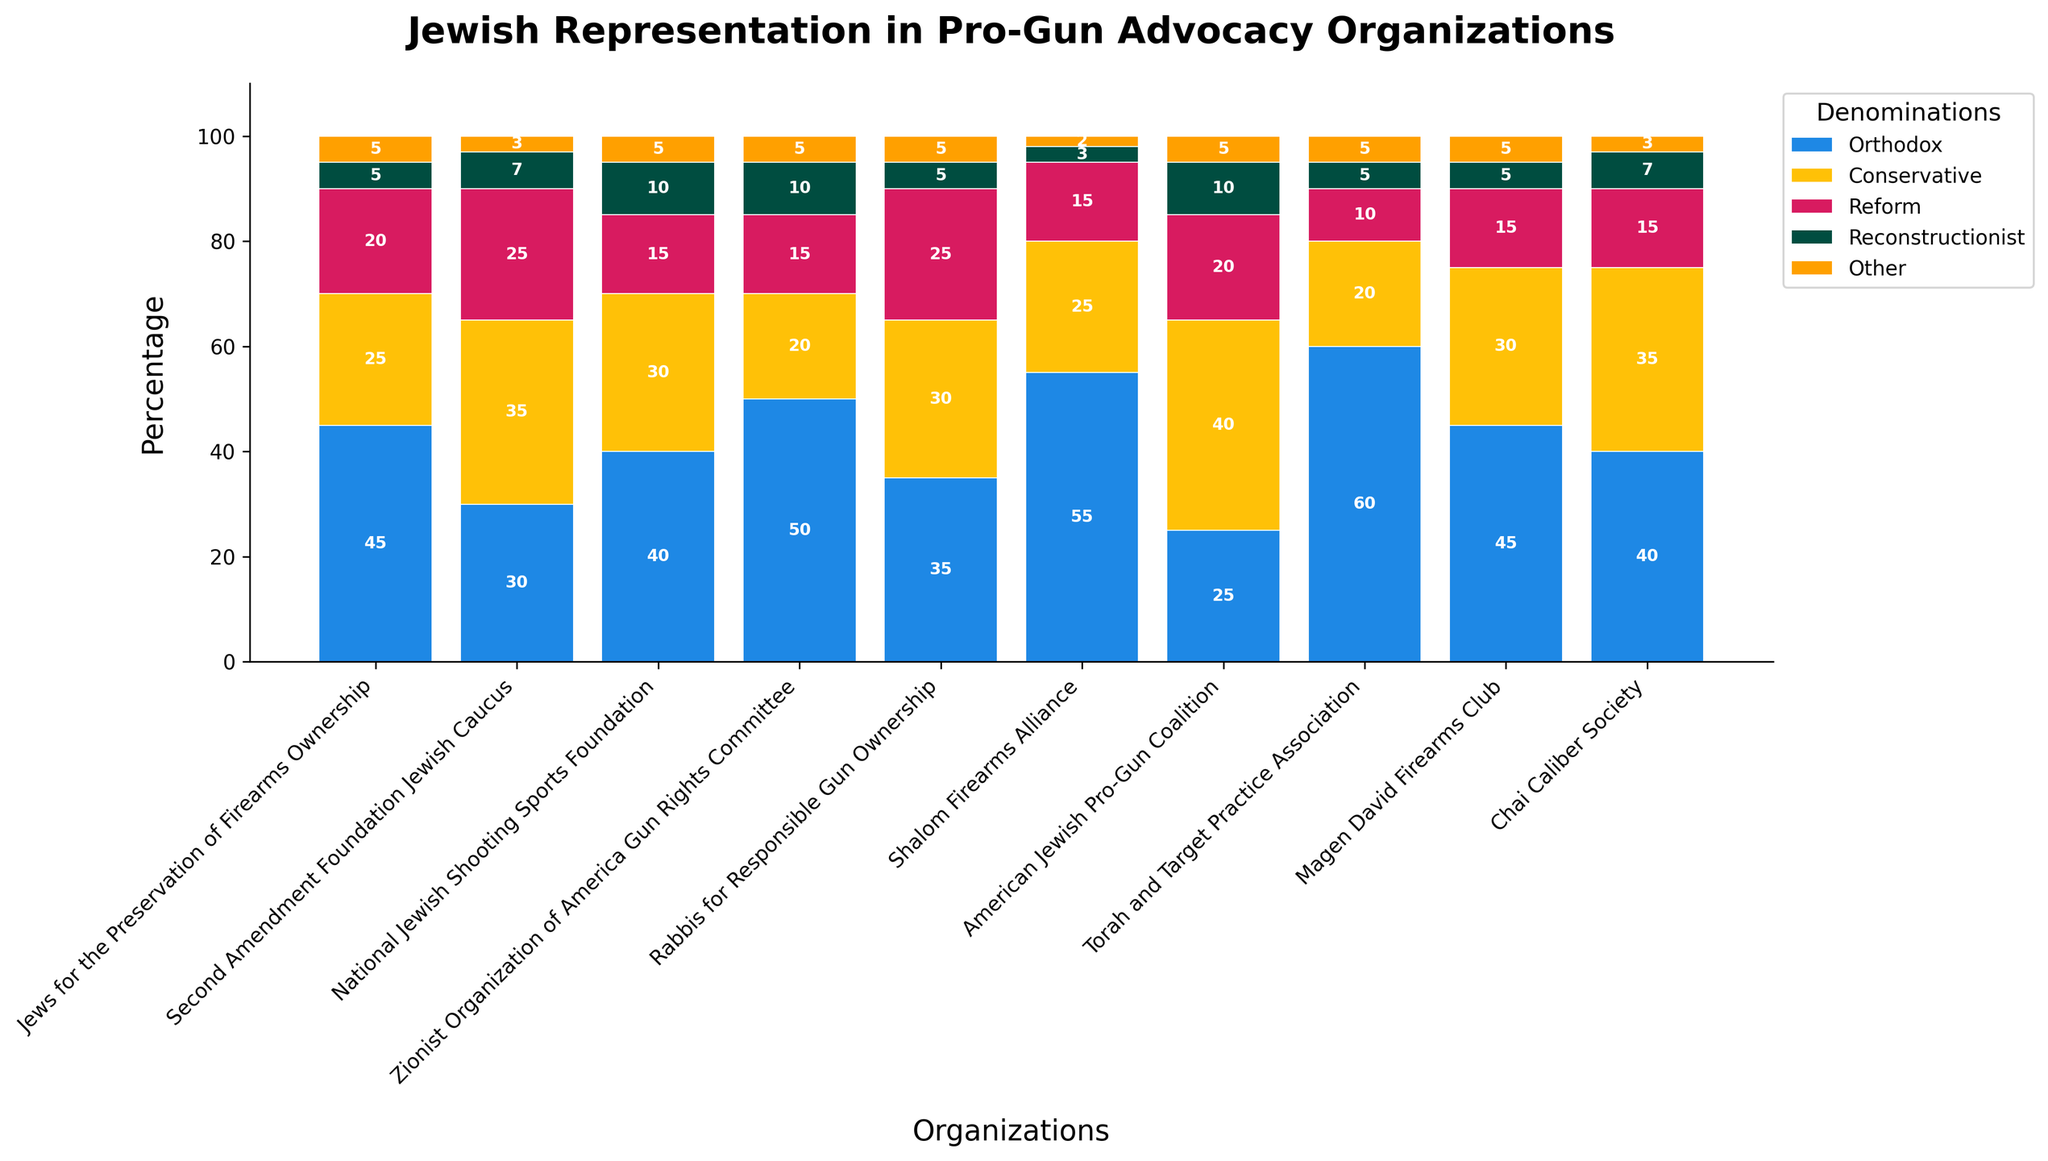What percentage of the Second Amendment Foundation Jewish Caucus constitutes Conservative Jews and Reform Jews combined? First, look at the percentage of Conservative Jews, which is 35%. Then look at the percentage of Reform Jews, which is 25%. Add them together: 35% + 25% = 60%.
Answer: 60% Which organization has the highest percentage of Orthodox Jews? Identify the organization with the tallest blue segment (representing Orthodox Jews). The Torah and Target Practice Association has the tallest blue segment at 60%.
Answer: Torah and Target Practice Association Compare the representation of Reconstructionist Jews in the National Jewish Shooting Sports Foundation and the Zionist Organization of America Gun Rights Committee. Which one has a higher percentage? Compare the height of the green segments representing Reconstructionist Jews. Both organizations have a green segment at 10%, so they have the same percentage.
Answer: Both are equal What is the total representation percentage of the "Other" category across all organizations? Sum the percentages of the Other category from all the organizations: 5+3+5+5+5+2+5+5+5+3 = 43%.
Answer: 43% Which pro-gun advocacy organization has the lowest total percentage of Conservative Jews? Identify the shortest yellow segment (representing Conservative Jews). The Zionist Organization of America Gun Rights Committee has the smallest percentage at 20%.
Answer: Zionist Organization of America Gun Rights Committee Evaluate the difference in representation of Orthodox Jews between the Shalom Firearms Alliance and the American Jewish Pro-Gun Coalition. The percentage of Orthodox Jews in the Shalom Firearms Alliance is 55%. In the American Jewish Pro-Gun Coalition, it is 25%. The difference is 55% - 25% = 30%.
Answer: 30% How does the representation of Reform Jews in Rabbis for Responsible Gun Ownership compare to that in Chai Caliber Society? Compare the height of the pink segments. Both organizations have a Reform representation of 25% and 15%, respectively. Thus, Rabbis for Responsible Gun Ownership has a higher representation (25% compared to 15%).
Answer: Rabbis for Responsible Gun Ownership has a higher representation Which group has the most balanced representation of all denominations? Look for an organization where the segments (colors) appear most even or similarly sized. The Second Amendment Foundation Jewish Caucus has relatively balanced segments with 30%, 35%, 25%, 7%, and 3%.
Answer: Second Amendment Foundation Jewish Caucus Is the representation of Orthodox Jews in the Magen David Firearms Club greater than 40%? Examine the height of the blue segment in the Magen David Firearms Club. It shows 45%, which is greater than 40%.
Answer: Yes, it is greater than 40% What’s the sum of Reform and Reconstructionist percentages for the American Jewish Pro-Gun Coalition? First, identify the Reform percentage which is 20%, and the Reconstructionist percentage which is 10%. Sum them: 20% + 10% = 30%.
Answer: 30% 